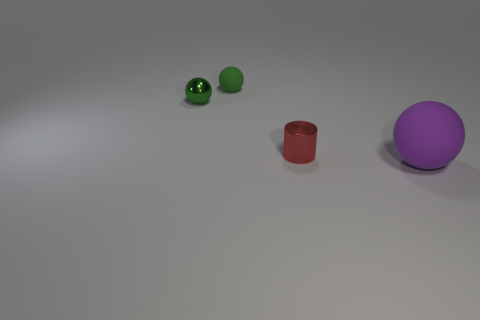Subtract all gray cylinders. Subtract all purple cubes. How many cylinders are left? 1 Add 2 small green metal balls. How many objects exist? 6 Subtract all spheres. How many objects are left? 1 Subtract all large rubber objects. Subtract all small green metal objects. How many objects are left? 2 Add 3 small metal things. How many small metal things are left? 5 Add 3 tiny shiny cylinders. How many tiny shiny cylinders exist? 4 Subtract 0 gray blocks. How many objects are left? 4 